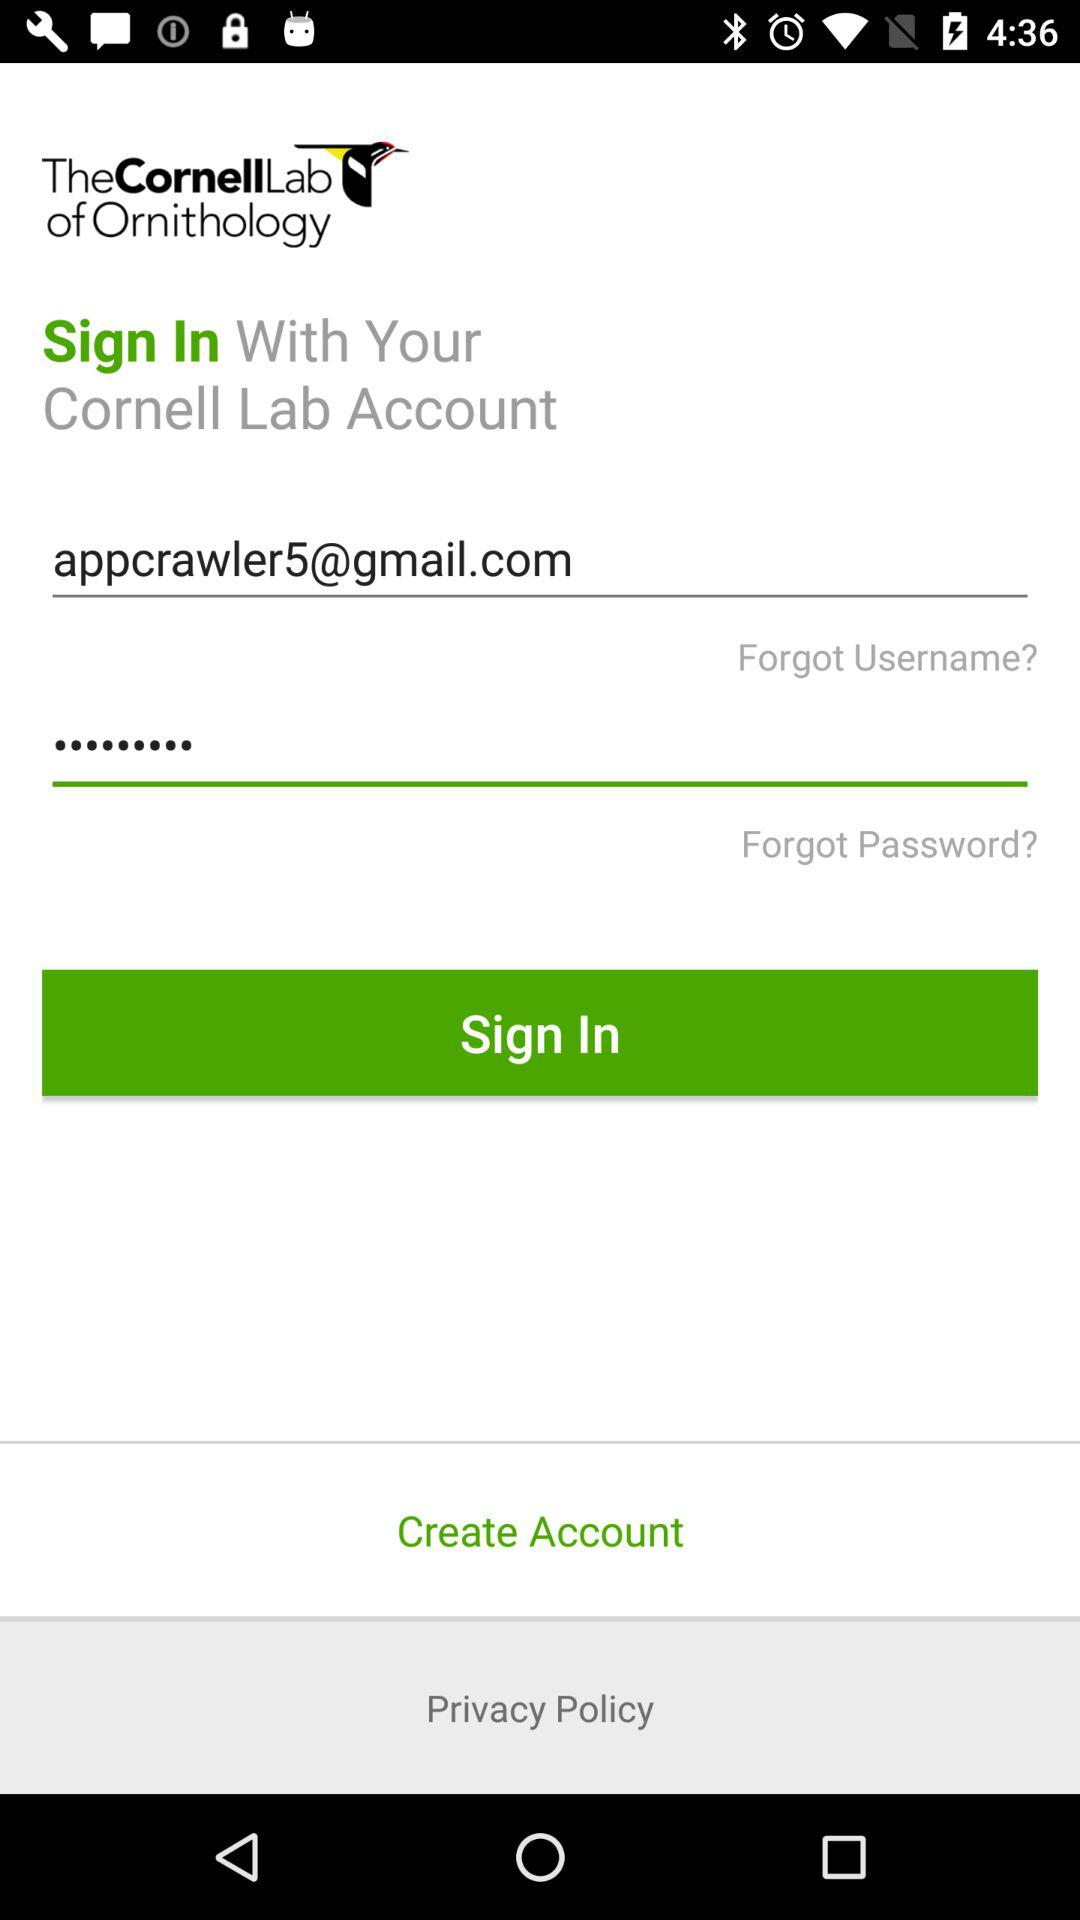What is the developer name? The developer name is The Cornell Lab of Ornithology. 